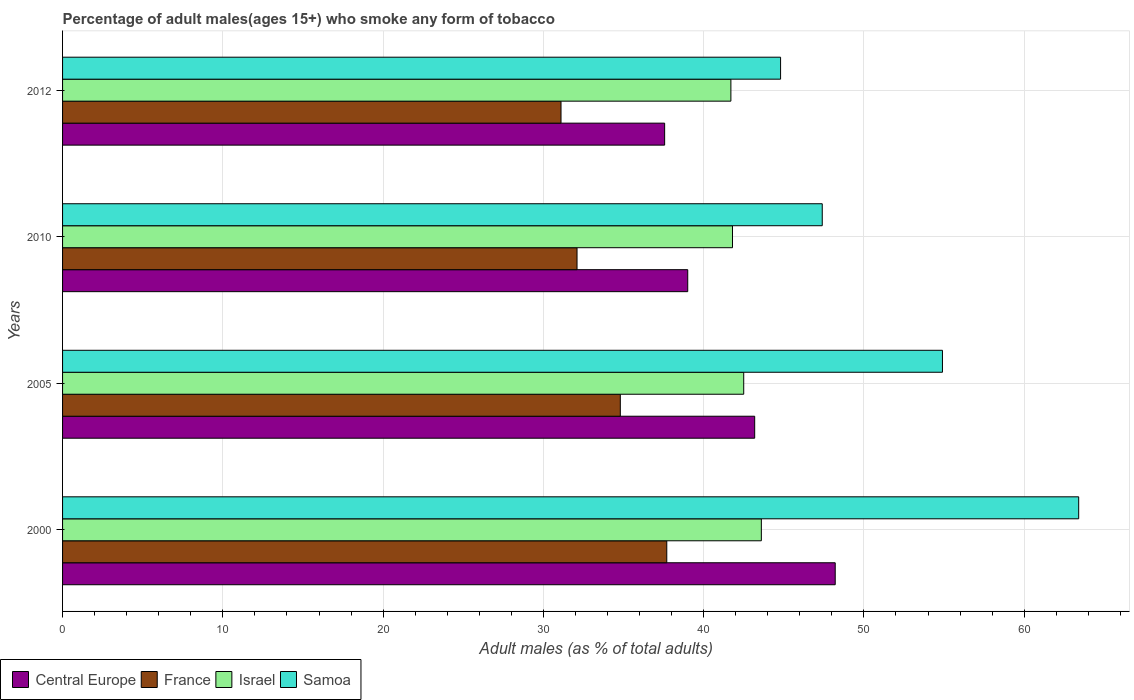How many groups of bars are there?
Your answer should be very brief. 4. Are the number of bars per tick equal to the number of legend labels?
Your answer should be compact. Yes. Are the number of bars on each tick of the Y-axis equal?
Your response must be concise. Yes. How many bars are there on the 4th tick from the top?
Offer a terse response. 4. How many bars are there on the 4th tick from the bottom?
Your answer should be very brief. 4. In how many cases, is the number of bars for a given year not equal to the number of legend labels?
Ensure brevity in your answer.  0. What is the percentage of adult males who smoke in Samoa in 2010?
Offer a very short reply. 47.4. Across all years, what is the maximum percentage of adult males who smoke in Samoa?
Your answer should be compact. 63.4. Across all years, what is the minimum percentage of adult males who smoke in Samoa?
Your answer should be compact. 44.8. In which year was the percentage of adult males who smoke in Israel minimum?
Keep it short and to the point. 2012. What is the total percentage of adult males who smoke in Samoa in the graph?
Provide a succinct answer. 210.5. What is the difference between the percentage of adult males who smoke in Samoa in 2010 and the percentage of adult males who smoke in France in 2000?
Make the answer very short. 9.7. What is the average percentage of adult males who smoke in Central Europe per year?
Your answer should be very brief. 41.99. In the year 2010, what is the difference between the percentage of adult males who smoke in Samoa and percentage of adult males who smoke in Central Europe?
Offer a very short reply. 8.39. In how many years, is the percentage of adult males who smoke in France greater than 12 %?
Ensure brevity in your answer.  4. What is the ratio of the percentage of adult males who smoke in Israel in 2000 to that in 2012?
Give a very brief answer. 1.05. Is the percentage of adult males who smoke in Central Europe in 2005 less than that in 2012?
Ensure brevity in your answer.  No. What is the difference between the highest and the second highest percentage of adult males who smoke in Israel?
Offer a very short reply. 1.1. What is the difference between the highest and the lowest percentage of adult males who smoke in Samoa?
Ensure brevity in your answer.  18.6. Is the sum of the percentage of adult males who smoke in France in 2005 and 2010 greater than the maximum percentage of adult males who smoke in Samoa across all years?
Offer a very short reply. Yes. What does the 3rd bar from the top in 2000 represents?
Give a very brief answer. France. What does the 4th bar from the bottom in 2010 represents?
Your response must be concise. Samoa. Is it the case that in every year, the sum of the percentage of adult males who smoke in Samoa and percentage of adult males who smoke in Israel is greater than the percentage of adult males who smoke in France?
Keep it short and to the point. Yes. How many bars are there?
Make the answer very short. 16. Are all the bars in the graph horizontal?
Offer a very short reply. Yes. How many years are there in the graph?
Make the answer very short. 4. What is the difference between two consecutive major ticks on the X-axis?
Make the answer very short. 10. Does the graph contain any zero values?
Ensure brevity in your answer.  No. How many legend labels are there?
Give a very brief answer. 4. What is the title of the graph?
Keep it short and to the point. Percentage of adult males(ages 15+) who smoke any form of tobacco. Does "Faeroe Islands" appear as one of the legend labels in the graph?
Your answer should be compact. No. What is the label or title of the X-axis?
Offer a terse response. Adult males (as % of total adults). What is the Adult males (as % of total adults) in Central Europe in 2000?
Your response must be concise. 48.21. What is the Adult males (as % of total adults) in France in 2000?
Keep it short and to the point. 37.7. What is the Adult males (as % of total adults) of Israel in 2000?
Your answer should be compact. 43.6. What is the Adult males (as % of total adults) of Samoa in 2000?
Your answer should be very brief. 63.4. What is the Adult males (as % of total adults) of Central Europe in 2005?
Offer a very short reply. 43.18. What is the Adult males (as % of total adults) of France in 2005?
Give a very brief answer. 34.8. What is the Adult males (as % of total adults) of Israel in 2005?
Your answer should be compact. 42.5. What is the Adult males (as % of total adults) in Samoa in 2005?
Your response must be concise. 54.9. What is the Adult males (as % of total adults) in Central Europe in 2010?
Ensure brevity in your answer.  39.01. What is the Adult males (as % of total adults) of France in 2010?
Your answer should be compact. 32.1. What is the Adult males (as % of total adults) in Israel in 2010?
Your answer should be compact. 41.8. What is the Adult males (as % of total adults) of Samoa in 2010?
Keep it short and to the point. 47.4. What is the Adult males (as % of total adults) of Central Europe in 2012?
Give a very brief answer. 37.57. What is the Adult males (as % of total adults) of France in 2012?
Offer a very short reply. 31.1. What is the Adult males (as % of total adults) of Israel in 2012?
Offer a terse response. 41.7. What is the Adult males (as % of total adults) of Samoa in 2012?
Provide a succinct answer. 44.8. Across all years, what is the maximum Adult males (as % of total adults) in Central Europe?
Keep it short and to the point. 48.21. Across all years, what is the maximum Adult males (as % of total adults) in France?
Your response must be concise. 37.7. Across all years, what is the maximum Adult males (as % of total adults) in Israel?
Make the answer very short. 43.6. Across all years, what is the maximum Adult males (as % of total adults) of Samoa?
Your answer should be compact. 63.4. Across all years, what is the minimum Adult males (as % of total adults) of Central Europe?
Give a very brief answer. 37.57. Across all years, what is the minimum Adult males (as % of total adults) in France?
Give a very brief answer. 31.1. Across all years, what is the minimum Adult males (as % of total adults) of Israel?
Make the answer very short. 41.7. Across all years, what is the minimum Adult males (as % of total adults) in Samoa?
Keep it short and to the point. 44.8. What is the total Adult males (as % of total adults) in Central Europe in the graph?
Make the answer very short. 167.97. What is the total Adult males (as % of total adults) in France in the graph?
Keep it short and to the point. 135.7. What is the total Adult males (as % of total adults) of Israel in the graph?
Provide a succinct answer. 169.6. What is the total Adult males (as % of total adults) in Samoa in the graph?
Offer a terse response. 210.5. What is the difference between the Adult males (as % of total adults) of Central Europe in 2000 and that in 2005?
Provide a succinct answer. 5.02. What is the difference between the Adult males (as % of total adults) of Samoa in 2000 and that in 2005?
Ensure brevity in your answer.  8.5. What is the difference between the Adult males (as % of total adults) in Central Europe in 2000 and that in 2010?
Offer a terse response. 9.2. What is the difference between the Adult males (as % of total adults) of France in 2000 and that in 2010?
Offer a terse response. 5.6. What is the difference between the Adult males (as % of total adults) of Israel in 2000 and that in 2010?
Keep it short and to the point. 1.8. What is the difference between the Adult males (as % of total adults) in Central Europe in 2000 and that in 2012?
Your answer should be very brief. 10.64. What is the difference between the Adult males (as % of total adults) of Israel in 2000 and that in 2012?
Ensure brevity in your answer.  1.9. What is the difference between the Adult males (as % of total adults) in Central Europe in 2005 and that in 2010?
Your response must be concise. 4.18. What is the difference between the Adult males (as % of total adults) of Samoa in 2005 and that in 2010?
Make the answer very short. 7.5. What is the difference between the Adult males (as % of total adults) of Central Europe in 2005 and that in 2012?
Provide a short and direct response. 5.62. What is the difference between the Adult males (as % of total adults) of France in 2005 and that in 2012?
Provide a succinct answer. 3.7. What is the difference between the Adult males (as % of total adults) of Samoa in 2005 and that in 2012?
Offer a terse response. 10.1. What is the difference between the Adult males (as % of total adults) of Central Europe in 2010 and that in 2012?
Your response must be concise. 1.44. What is the difference between the Adult males (as % of total adults) of Samoa in 2010 and that in 2012?
Offer a very short reply. 2.6. What is the difference between the Adult males (as % of total adults) of Central Europe in 2000 and the Adult males (as % of total adults) of France in 2005?
Provide a short and direct response. 13.41. What is the difference between the Adult males (as % of total adults) of Central Europe in 2000 and the Adult males (as % of total adults) of Israel in 2005?
Offer a very short reply. 5.71. What is the difference between the Adult males (as % of total adults) of Central Europe in 2000 and the Adult males (as % of total adults) of Samoa in 2005?
Your answer should be very brief. -6.69. What is the difference between the Adult males (as % of total adults) of France in 2000 and the Adult males (as % of total adults) of Israel in 2005?
Provide a short and direct response. -4.8. What is the difference between the Adult males (as % of total adults) in France in 2000 and the Adult males (as % of total adults) in Samoa in 2005?
Provide a succinct answer. -17.2. What is the difference between the Adult males (as % of total adults) in Central Europe in 2000 and the Adult males (as % of total adults) in France in 2010?
Provide a short and direct response. 16.11. What is the difference between the Adult males (as % of total adults) in Central Europe in 2000 and the Adult males (as % of total adults) in Israel in 2010?
Make the answer very short. 6.41. What is the difference between the Adult males (as % of total adults) in Central Europe in 2000 and the Adult males (as % of total adults) in Samoa in 2010?
Your answer should be compact. 0.81. What is the difference between the Adult males (as % of total adults) of France in 2000 and the Adult males (as % of total adults) of Israel in 2010?
Keep it short and to the point. -4.1. What is the difference between the Adult males (as % of total adults) in France in 2000 and the Adult males (as % of total adults) in Samoa in 2010?
Your answer should be compact. -9.7. What is the difference between the Adult males (as % of total adults) in Israel in 2000 and the Adult males (as % of total adults) in Samoa in 2010?
Ensure brevity in your answer.  -3.8. What is the difference between the Adult males (as % of total adults) of Central Europe in 2000 and the Adult males (as % of total adults) of France in 2012?
Provide a succinct answer. 17.11. What is the difference between the Adult males (as % of total adults) of Central Europe in 2000 and the Adult males (as % of total adults) of Israel in 2012?
Offer a terse response. 6.51. What is the difference between the Adult males (as % of total adults) of Central Europe in 2000 and the Adult males (as % of total adults) of Samoa in 2012?
Your answer should be very brief. 3.41. What is the difference between the Adult males (as % of total adults) of France in 2000 and the Adult males (as % of total adults) of Israel in 2012?
Offer a very short reply. -4. What is the difference between the Adult males (as % of total adults) of Israel in 2000 and the Adult males (as % of total adults) of Samoa in 2012?
Make the answer very short. -1.2. What is the difference between the Adult males (as % of total adults) in Central Europe in 2005 and the Adult males (as % of total adults) in France in 2010?
Ensure brevity in your answer.  11.08. What is the difference between the Adult males (as % of total adults) in Central Europe in 2005 and the Adult males (as % of total adults) in Israel in 2010?
Offer a terse response. 1.38. What is the difference between the Adult males (as % of total adults) of Central Europe in 2005 and the Adult males (as % of total adults) of Samoa in 2010?
Keep it short and to the point. -4.22. What is the difference between the Adult males (as % of total adults) in France in 2005 and the Adult males (as % of total adults) in Israel in 2010?
Keep it short and to the point. -7. What is the difference between the Adult males (as % of total adults) of Central Europe in 2005 and the Adult males (as % of total adults) of France in 2012?
Your response must be concise. 12.08. What is the difference between the Adult males (as % of total adults) of Central Europe in 2005 and the Adult males (as % of total adults) of Israel in 2012?
Provide a short and direct response. 1.48. What is the difference between the Adult males (as % of total adults) in Central Europe in 2005 and the Adult males (as % of total adults) in Samoa in 2012?
Your response must be concise. -1.62. What is the difference between the Adult males (as % of total adults) in France in 2005 and the Adult males (as % of total adults) in Israel in 2012?
Keep it short and to the point. -6.9. What is the difference between the Adult males (as % of total adults) in France in 2005 and the Adult males (as % of total adults) in Samoa in 2012?
Your answer should be very brief. -10. What is the difference between the Adult males (as % of total adults) in Israel in 2005 and the Adult males (as % of total adults) in Samoa in 2012?
Your response must be concise. -2.3. What is the difference between the Adult males (as % of total adults) in Central Europe in 2010 and the Adult males (as % of total adults) in France in 2012?
Make the answer very short. 7.91. What is the difference between the Adult males (as % of total adults) in Central Europe in 2010 and the Adult males (as % of total adults) in Israel in 2012?
Your answer should be very brief. -2.69. What is the difference between the Adult males (as % of total adults) in Central Europe in 2010 and the Adult males (as % of total adults) in Samoa in 2012?
Provide a succinct answer. -5.79. What is the difference between the Adult males (as % of total adults) in France in 2010 and the Adult males (as % of total adults) in Israel in 2012?
Your response must be concise. -9.6. What is the average Adult males (as % of total adults) of Central Europe per year?
Your response must be concise. 41.99. What is the average Adult males (as % of total adults) in France per year?
Offer a terse response. 33.92. What is the average Adult males (as % of total adults) of Israel per year?
Ensure brevity in your answer.  42.4. What is the average Adult males (as % of total adults) in Samoa per year?
Keep it short and to the point. 52.62. In the year 2000, what is the difference between the Adult males (as % of total adults) of Central Europe and Adult males (as % of total adults) of France?
Provide a short and direct response. 10.51. In the year 2000, what is the difference between the Adult males (as % of total adults) of Central Europe and Adult males (as % of total adults) of Israel?
Your answer should be very brief. 4.61. In the year 2000, what is the difference between the Adult males (as % of total adults) in Central Europe and Adult males (as % of total adults) in Samoa?
Ensure brevity in your answer.  -15.19. In the year 2000, what is the difference between the Adult males (as % of total adults) in France and Adult males (as % of total adults) in Samoa?
Give a very brief answer. -25.7. In the year 2000, what is the difference between the Adult males (as % of total adults) in Israel and Adult males (as % of total adults) in Samoa?
Offer a very short reply. -19.8. In the year 2005, what is the difference between the Adult males (as % of total adults) of Central Europe and Adult males (as % of total adults) of France?
Ensure brevity in your answer.  8.38. In the year 2005, what is the difference between the Adult males (as % of total adults) in Central Europe and Adult males (as % of total adults) in Israel?
Provide a succinct answer. 0.68. In the year 2005, what is the difference between the Adult males (as % of total adults) of Central Europe and Adult males (as % of total adults) of Samoa?
Your answer should be compact. -11.72. In the year 2005, what is the difference between the Adult males (as % of total adults) of France and Adult males (as % of total adults) of Israel?
Ensure brevity in your answer.  -7.7. In the year 2005, what is the difference between the Adult males (as % of total adults) of France and Adult males (as % of total adults) of Samoa?
Provide a short and direct response. -20.1. In the year 2010, what is the difference between the Adult males (as % of total adults) of Central Europe and Adult males (as % of total adults) of France?
Your response must be concise. 6.91. In the year 2010, what is the difference between the Adult males (as % of total adults) in Central Europe and Adult males (as % of total adults) in Israel?
Make the answer very short. -2.79. In the year 2010, what is the difference between the Adult males (as % of total adults) of Central Europe and Adult males (as % of total adults) of Samoa?
Your answer should be compact. -8.39. In the year 2010, what is the difference between the Adult males (as % of total adults) of France and Adult males (as % of total adults) of Israel?
Offer a terse response. -9.7. In the year 2010, what is the difference between the Adult males (as % of total adults) of France and Adult males (as % of total adults) of Samoa?
Provide a short and direct response. -15.3. In the year 2012, what is the difference between the Adult males (as % of total adults) of Central Europe and Adult males (as % of total adults) of France?
Ensure brevity in your answer.  6.47. In the year 2012, what is the difference between the Adult males (as % of total adults) in Central Europe and Adult males (as % of total adults) in Israel?
Ensure brevity in your answer.  -4.13. In the year 2012, what is the difference between the Adult males (as % of total adults) in Central Europe and Adult males (as % of total adults) in Samoa?
Offer a terse response. -7.23. In the year 2012, what is the difference between the Adult males (as % of total adults) of France and Adult males (as % of total adults) of Israel?
Make the answer very short. -10.6. In the year 2012, what is the difference between the Adult males (as % of total adults) in France and Adult males (as % of total adults) in Samoa?
Your answer should be compact. -13.7. What is the ratio of the Adult males (as % of total adults) in Central Europe in 2000 to that in 2005?
Your answer should be compact. 1.12. What is the ratio of the Adult males (as % of total adults) in Israel in 2000 to that in 2005?
Your answer should be compact. 1.03. What is the ratio of the Adult males (as % of total adults) of Samoa in 2000 to that in 2005?
Give a very brief answer. 1.15. What is the ratio of the Adult males (as % of total adults) in Central Europe in 2000 to that in 2010?
Your response must be concise. 1.24. What is the ratio of the Adult males (as % of total adults) of France in 2000 to that in 2010?
Your answer should be compact. 1.17. What is the ratio of the Adult males (as % of total adults) of Israel in 2000 to that in 2010?
Your response must be concise. 1.04. What is the ratio of the Adult males (as % of total adults) in Samoa in 2000 to that in 2010?
Your response must be concise. 1.34. What is the ratio of the Adult males (as % of total adults) in Central Europe in 2000 to that in 2012?
Offer a terse response. 1.28. What is the ratio of the Adult males (as % of total adults) in France in 2000 to that in 2012?
Keep it short and to the point. 1.21. What is the ratio of the Adult males (as % of total adults) of Israel in 2000 to that in 2012?
Offer a terse response. 1.05. What is the ratio of the Adult males (as % of total adults) of Samoa in 2000 to that in 2012?
Make the answer very short. 1.42. What is the ratio of the Adult males (as % of total adults) of Central Europe in 2005 to that in 2010?
Keep it short and to the point. 1.11. What is the ratio of the Adult males (as % of total adults) in France in 2005 to that in 2010?
Offer a very short reply. 1.08. What is the ratio of the Adult males (as % of total adults) in Israel in 2005 to that in 2010?
Offer a very short reply. 1.02. What is the ratio of the Adult males (as % of total adults) in Samoa in 2005 to that in 2010?
Provide a short and direct response. 1.16. What is the ratio of the Adult males (as % of total adults) of Central Europe in 2005 to that in 2012?
Provide a short and direct response. 1.15. What is the ratio of the Adult males (as % of total adults) of France in 2005 to that in 2012?
Your answer should be compact. 1.12. What is the ratio of the Adult males (as % of total adults) of Israel in 2005 to that in 2012?
Provide a short and direct response. 1.02. What is the ratio of the Adult males (as % of total adults) in Samoa in 2005 to that in 2012?
Your response must be concise. 1.23. What is the ratio of the Adult males (as % of total adults) in Central Europe in 2010 to that in 2012?
Keep it short and to the point. 1.04. What is the ratio of the Adult males (as % of total adults) in France in 2010 to that in 2012?
Your response must be concise. 1.03. What is the ratio of the Adult males (as % of total adults) of Israel in 2010 to that in 2012?
Provide a short and direct response. 1. What is the ratio of the Adult males (as % of total adults) in Samoa in 2010 to that in 2012?
Your answer should be compact. 1.06. What is the difference between the highest and the second highest Adult males (as % of total adults) of Central Europe?
Offer a terse response. 5.02. What is the difference between the highest and the second highest Adult males (as % of total adults) in France?
Provide a short and direct response. 2.9. What is the difference between the highest and the second highest Adult males (as % of total adults) of Samoa?
Provide a succinct answer. 8.5. What is the difference between the highest and the lowest Adult males (as % of total adults) of Central Europe?
Your answer should be very brief. 10.64. What is the difference between the highest and the lowest Adult males (as % of total adults) in France?
Keep it short and to the point. 6.6. What is the difference between the highest and the lowest Adult males (as % of total adults) in Israel?
Your answer should be compact. 1.9. What is the difference between the highest and the lowest Adult males (as % of total adults) in Samoa?
Offer a very short reply. 18.6. 